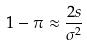Convert formula to latex. <formula><loc_0><loc_0><loc_500><loc_500>1 - \pi \approx \frac { 2 s } { \sigma ^ { 2 } }</formula> 